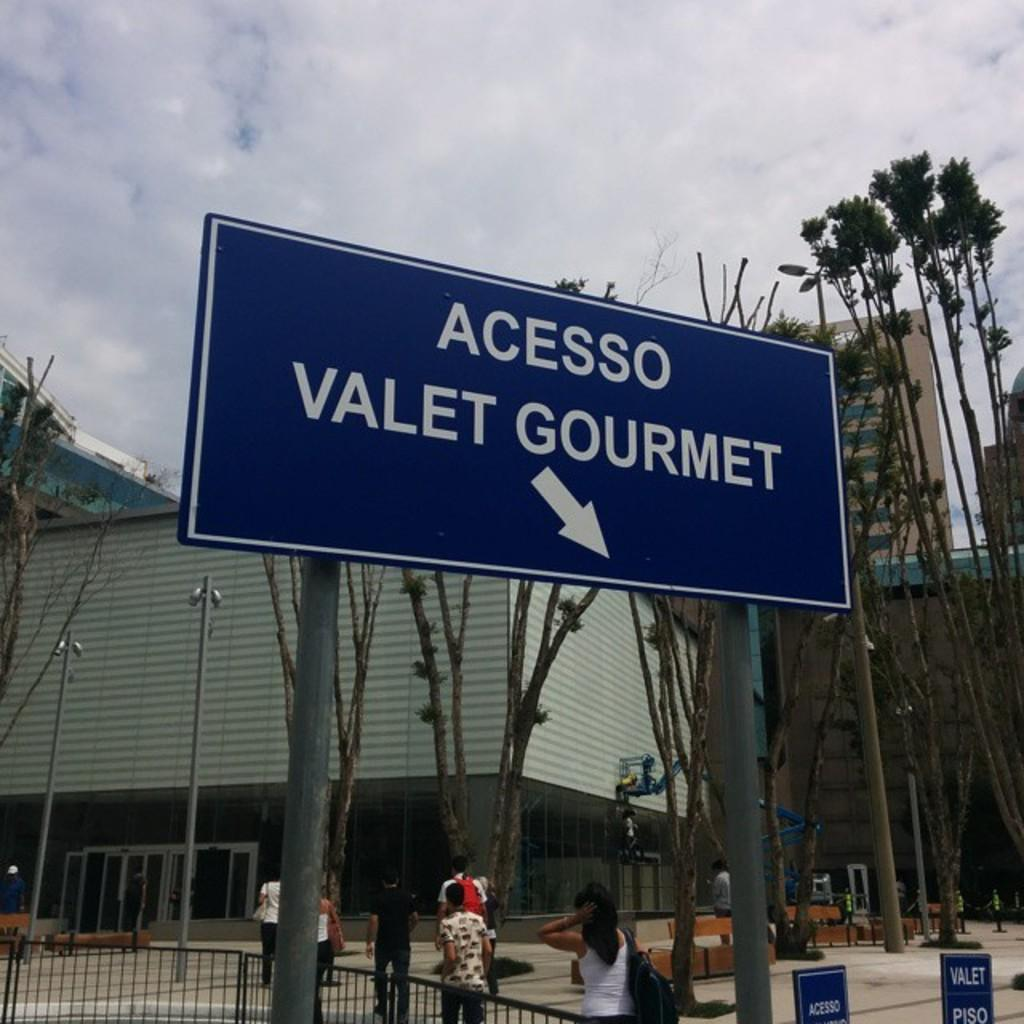<image>
Relay a brief, clear account of the picture shown. The sign for Acesso Valet Gourmet is in front of a building. 